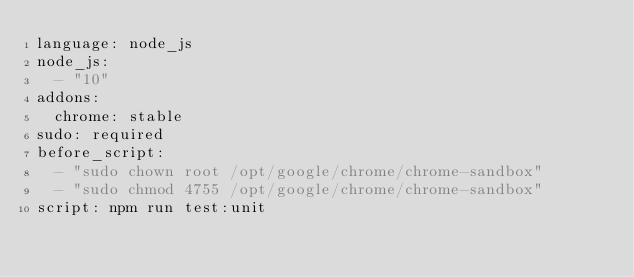<code> <loc_0><loc_0><loc_500><loc_500><_YAML_>language: node_js
node_js:
  - "10"
addons:
  chrome: stable
sudo: required
before_script:
  - "sudo chown root /opt/google/chrome/chrome-sandbox"
  - "sudo chmod 4755 /opt/google/chrome/chrome-sandbox"
script: npm run test:unit</code> 